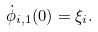<formula> <loc_0><loc_0><loc_500><loc_500>\dot { \phi } _ { i , 1 } ( 0 ) = \xi _ { i } .</formula> 